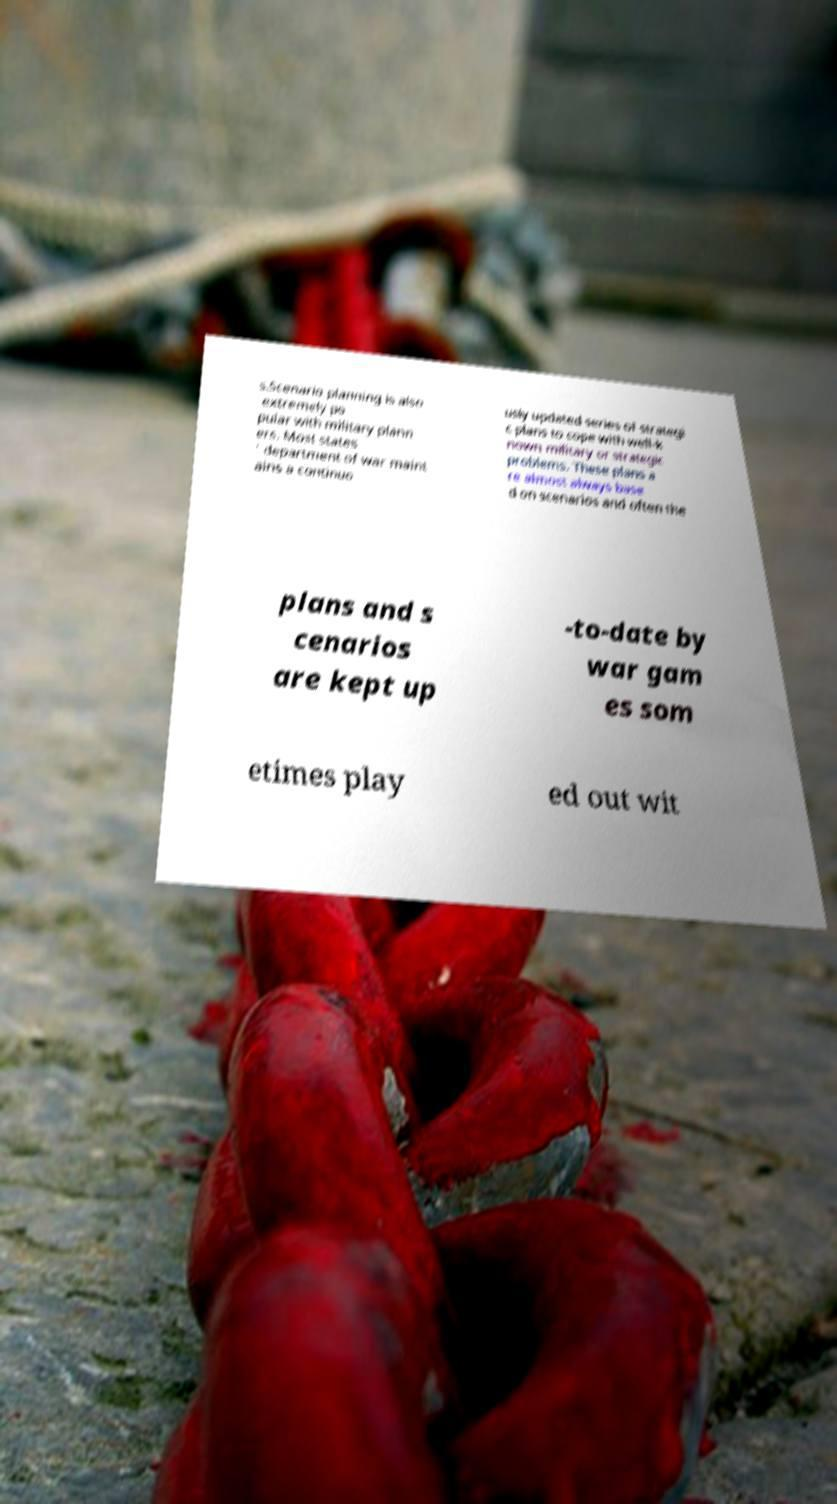For documentation purposes, I need the text within this image transcribed. Could you provide that? s.Scenario planning is also extremely po pular with military plann ers. Most states ' department of war maint ains a continuo usly updated series of strategi c plans to cope with well-k nown military or strategic problems. These plans a re almost always base d on scenarios and often the plans and s cenarios are kept up -to-date by war gam es som etimes play ed out wit 